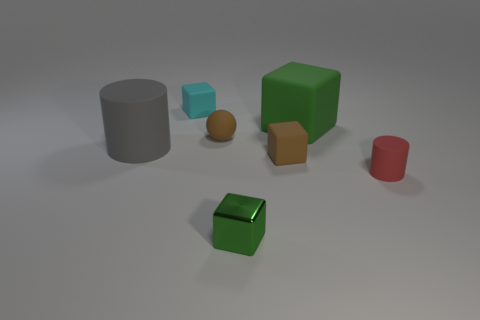Do the cyan cube and the cylinder that is left of the cyan rubber thing have the same material?
Give a very brief answer. Yes. The small shiny cube is what color?
Provide a short and direct response. Green. There is a big object in front of the brown matte ball; what shape is it?
Your response must be concise. Cylinder. What number of brown things are either big cylinders or small rubber blocks?
Your answer should be compact. 1. There is another big object that is made of the same material as the big gray thing; what is its color?
Your answer should be very brief. Green. Do the tiny metal object and the cylinder left of the small red thing have the same color?
Your answer should be very brief. No. What is the color of the object that is behind the brown rubber ball and on the left side of the tiny green cube?
Ensure brevity in your answer.  Cyan. What number of small metal things are behind the small red rubber object?
Keep it short and to the point. 0. What number of things are tiny cyan shiny cylinders or small brown things that are right of the small shiny block?
Your answer should be compact. 1. There is a small rubber cube that is in front of the cyan cube; is there a metallic cube that is right of it?
Provide a short and direct response. No. 